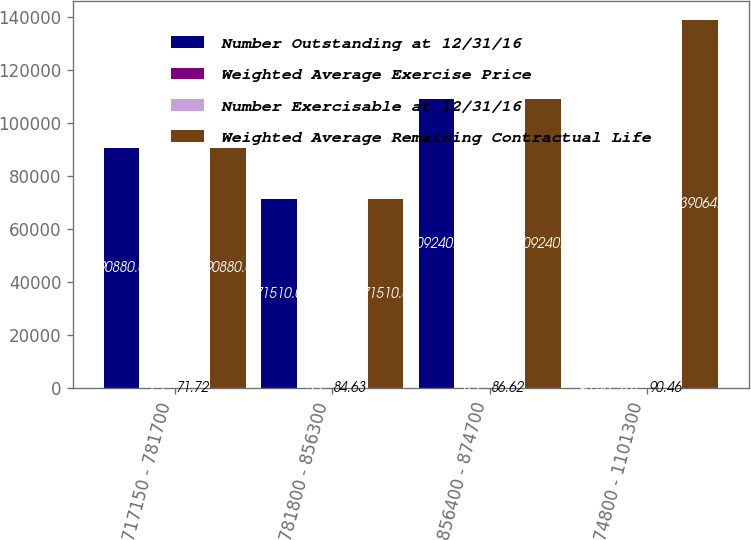Convert chart. <chart><loc_0><loc_0><loc_500><loc_500><stacked_bar_chart><ecel><fcel>717150 - 781700<fcel>781800 - 856300<fcel>856400 - 874700<fcel>874800 - 1101300<nl><fcel>Number Outstanding at 12/31/16<fcel>90880<fcel>71510<fcel>109240<fcel>90.46<nl><fcel>Weighted Average Exercise Price<fcel>2.1<fcel>3.1<fcel>4.1<fcel>4.4<nl><fcel>Number Exercisable at 12/31/16<fcel>71.72<fcel>84.63<fcel>86.62<fcel>90.46<nl><fcel>Weighted Average Remaining Contractual Life<fcel>90880<fcel>71510<fcel>109240<fcel>139064<nl></chart> 